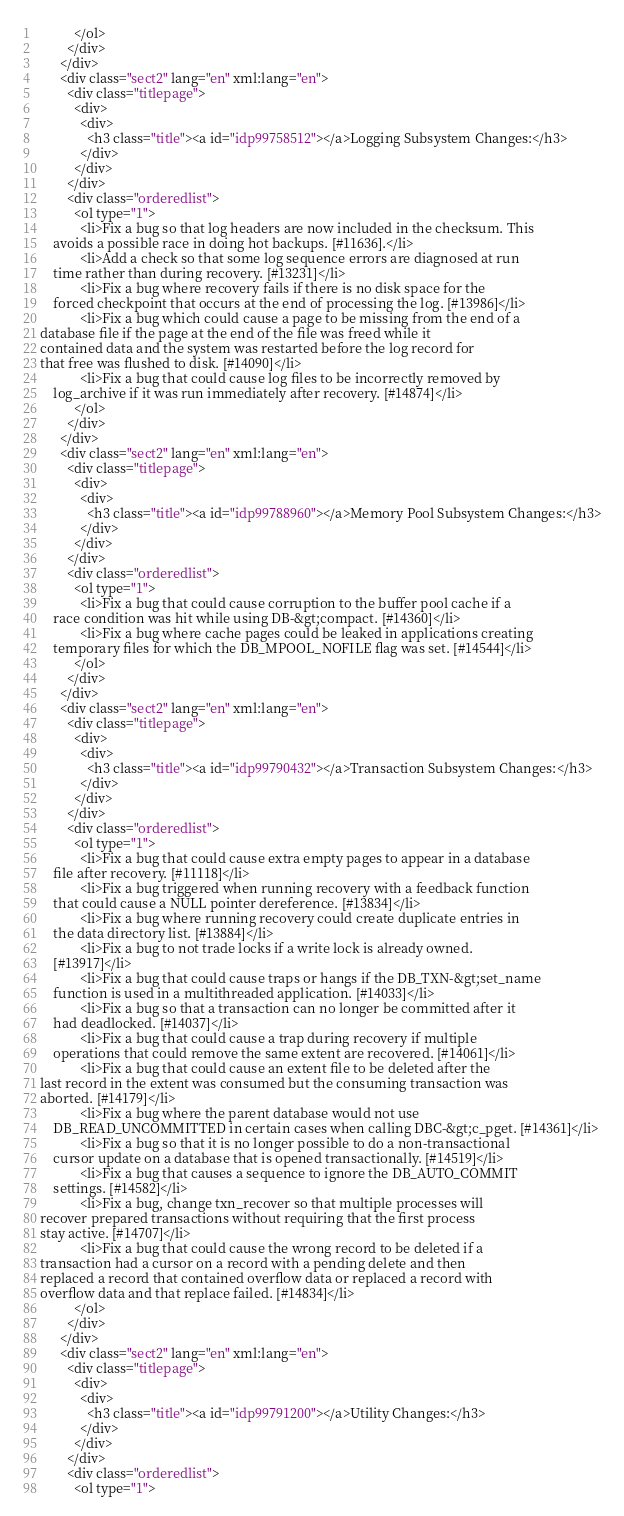<code> <loc_0><loc_0><loc_500><loc_500><_HTML_>          </ol>
        </div>
      </div>
      <div class="sect2" lang="en" xml:lang="en">
        <div class="titlepage">
          <div>
            <div>
              <h3 class="title"><a id="idp99758512"></a>Logging Subsystem Changes:</h3>
            </div>
          </div>
        </div>
        <div class="orderedlist">
          <ol type="1">
            <li>Fix a bug so that log headers are now included in the checksum. This
	avoids a possible race in doing hot backups. [#11636].</li>
            <li>Add a check so that some log sequence errors are diagnosed at run
	time rather than during recovery. [#13231]</li>
            <li>Fix a bug where recovery fails if there is no disk space for the
	forced checkpoint that occurs at the end of processing the log. [#13986]</li>
            <li>Fix a bug which could cause a page to be missing from the end of a
database file if the page at the end of the file was freed while it
contained data and the system was restarted before the log record for
that free was flushed to disk. [#14090]</li>
            <li>Fix a bug that could cause log files to be incorrectly removed by
	log_archive if it was run immediately after recovery. [#14874]</li>
          </ol>
        </div>
      </div>
      <div class="sect2" lang="en" xml:lang="en">
        <div class="titlepage">
          <div>
            <div>
              <h3 class="title"><a id="idp99788960"></a>Memory Pool Subsystem Changes:</h3>
            </div>
          </div>
        </div>
        <div class="orderedlist">
          <ol type="1">
            <li>Fix a bug that could cause corruption to the buffer pool cache if a
	race condition was hit while using DB-&gt;compact. [#14360]</li>
            <li>Fix a bug where cache pages could be leaked in applications creating
	temporary files for which the DB_MPOOL_NOFILE flag was set. [#14544]</li>
          </ol>
        </div>
      </div>
      <div class="sect2" lang="en" xml:lang="en">
        <div class="titlepage">
          <div>
            <div>
              <h3 class="title"><a id="idp99790432"></a>Transaction Subsystem Changes:</h3>
            </div>
          </div>
        </div>
        <div class="orderedlist">
          <ol type="1">
            <li>Fix a bug that could cause extra empty pages to appear in a database
	file after recovery. [#11118]</li>
            <li>Fix a bug triggered when running recovery with a feedback function
	that could cause a NULL pointer dereference. [#13834]</li>
            <li>Fix a bug where running recovery could create duplicate entries in
	the data directory list. [#13884]</li>
            <li>Fix a bug to not trade locks if a write lock is already owned.
	[#13917]</li>
            <li>Fix a bug that could cause traps or hangs if the DB_TXN-&gt;set_name
	function is used in a multithreaded application. [#14033]</li>
            <li>Fix a bug so that a transaction can no longer be committed after it
	had deadlocked. [#14037]</li>
            <li>Fix a bug that could cause a trap during recovery if multiple
	operations that could remove the same extent are recovered. [#14061]</li>
            <li>Fix a bug that could cause an extent file to be deleted after the
last record in the extent was consumed but the consuming transaction was
aborted. [#14179]</li>
            <li>Fix a bug where the parent database would not use
	DB_READ_UNCOMMITTED in certain cases when calling DBC-&gt;c_pget. [#14361]</li>
            <li>Fix a bug so that it is no longer possible to do a non-transactional
	cursor update on a database that is opened transactionally. [#14519]</li>
            <li>Fix a bug that causes a sequence to ignore the DB_AUTO_COMMIT
	settings. [#14582]</li>
            <li>Fix a bug, change txn_recover so that multiple processes will
recover prepared transactions without requiring that the first process
stay active. [#14707]</li>
            <li>Fix a bug that could cause the wrong record to be deleted if a
transaction had a cursor on a record with a pending delete and then
replaced a record that contained overflow data or replaced a record with
overflow data and that replace failed. [#14834]</li>
          </ol>
        </div>
      </div>
      <div class="sect2" lang="en" xml:lang="en">
        <div class="titlepage">
          <div>
            <div>
              <h3 class="title"><a id="idp99791200"></a>Utility Changes:</h3>
            </div>
          </div>
        </div>
        <div class="orderedlist">
          <ol type="1"></code> 